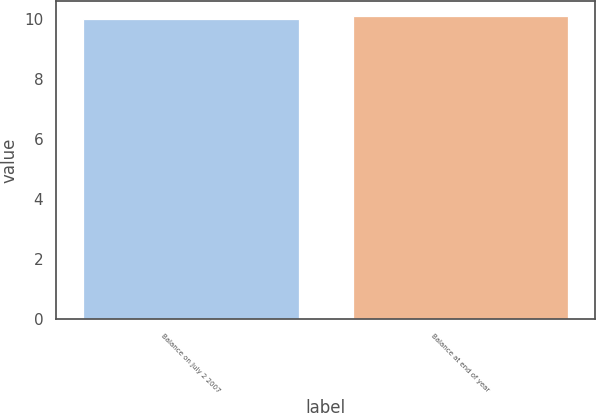Convert chart. <chart><loc_0><loc_0><loc_500><loc_500><bar_chart><fcel>Balance on July 2 2007<fcel>Balance at end of year<nl><fcel>10<fcel>10.1<nl></chart> 